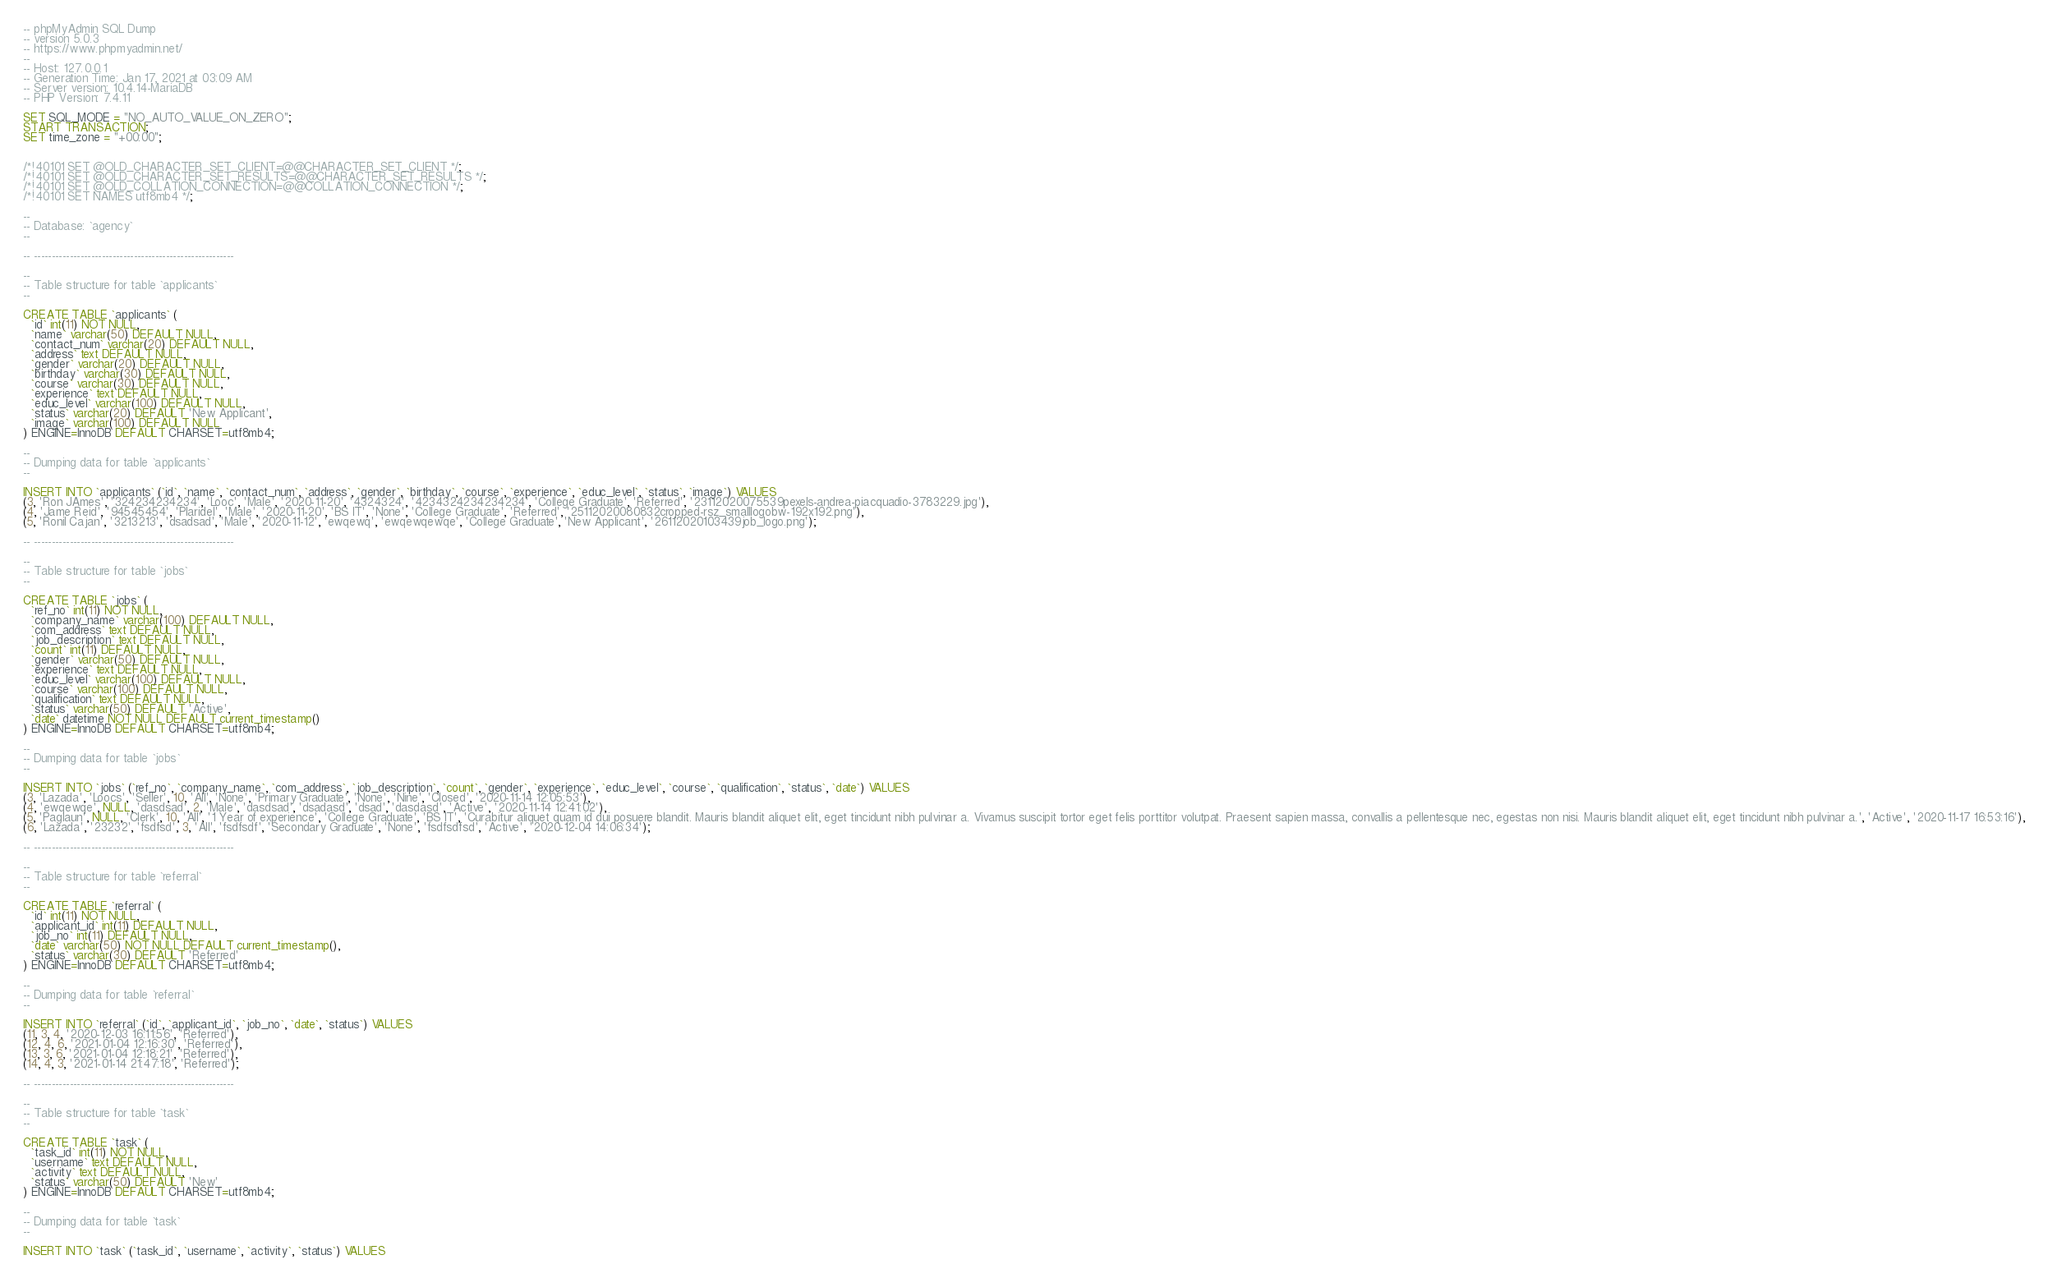Convert code to text. <code><loc_0><loc_0><loc_500><loc_500><_SQL_>-- phpMyAdmin SQL Dump
-- version 5.0.3
-- https://www.phpmyadmin.net/
--
-- Host: 127.0.0.1
-- Generation Time: Jan 17, 2021 at 03:09 AM
-- Server version: 10.4.14-MariaDB
-- PHP Version: 7.4.11

SET SQL_MODE = "NO_AUTO_VALUE_ON_ZERO";
START TRANSACTION;
SET time_zone = "+00:00";


/*!40101 SET @OLD_CHARACTER_SET_CLIENT=@@CHARACTER_SET_CLIENT */;
/*!40101 SET @OLD_CHARACTER_SET_RESULTS=@@CHARACTER_SET_RESULTS */;
/*!40101 SET @OLD_COLLATION_CONNECTION=@@COLLATION_CONNECTION */;
/*!40101 SET NAMES utf8mb4 */;

--
-- Database: `agency`
--

-- --------------------------------------------------------

--
-- Table structure for table `applicants`
--

CREATE TABLE `applicants` (
  `id` int(11) NOT NULL,
  `name` varchar(50) DEFAULT NULL,
  `contact_num` varchar(20) DEFAULT NULL,
  `address` text DEFAULT NULL,
  `gender` varchar(20) DEFAULT NULL,
  `birthday` varchar(30) DEFAULT NULL,
  `course` varchar(30) DEFAULT NULL,
  `experience` text DEFAULT NULL,
  `educ_level` varchar(100) DEFAULT NULL,
  `status` varchar(20) DEFAULT 'New Applicant',
  `image` varchar(100) DEFAULT NULL
) ENGINE=InnoDB DEFAULT CHARSET=utf8mb4;

--
-- Dumping data for table `applicants`
--

INSERT INTO `applicants` (`id`, `name`, `contact_num`, `address`, `gender`, `birthday`, `course`, `experience`, `educ_level`, `status`, `image`) VALUES
(3, 'Ron JAmes', '324234234234', 'Looc', 'Male', '2020-11-20', '4324324', '4234324234234234', 'College Graduate', 'Referred', '23112020075539pexels-andrea-piacquadio-3783229.jpg'),
(4, 'Jame Reid', '94545454', 'Plaridel', 'Male', '2020-11-20', 'BS IT', 'None', 'College Graduate', 'Referred', '25112020080832cropped-rsz_smalllogobw-192x192.png'),
(5, 'Ronil Cajan', '3213213', 'dsadsad', 'Male', '2020-11-12', 'ewqewq', 'ewqewqewqe', 'College Graduate', 'New Applicant', '26112020103439job_logo.png');

-- --------------------------------------------------------

--
-- Table structure for table `jobs`
--

CREATE TABLE `jobs` (
  `ref_no` int(11) NOT NULL,
  `company_name` varchar(100) DEFAULT NULL,
  `com_address` text DEFAULT NULL,
  `job_description` text DEFAULT NULL,
  `count` int(11) DEFAULT NULL,
  `gender` varchar(50) DEFAULT NULL,
  `experience` text DEFAULT NULL,
  `educ_level` varchar(100) DEFAULT NULL,
  `course` varchar(100) DEFAULT NULL,
  `qualification` text DEFAULT NULL,
  `status` varchar(50) DEFAULT 'Active',
  `date` datetime NOT NULL DEFAULT current_timestamp()
) ENGINE=InnoDB DEFAULT CHARSET=utf8mb4;

--
-- Dumping data for table `jobs`
--

INSERT INTO `jobs` (`ref_no`, `company_name`, `com_address`, `job_description`, `count`, `gender`, `experience`, `educ_level`, `course`, `qualification`, `status`, `date`) VALUES
(3, 'Lazada', 'Loocs', 'Seller', 10, 'All', 'None', 'Primary Graduate', 'None', 'Nine', 'Closed', '2020-11-14 12:05:53'),
(4, 'ewqewqe', NULL, 'dasdsad', 2, 'Male', 'dasdsad', 'dsadasd', 'dsad', 'dasdasd', 'Active', '2020-11-14 12:41:02'),
(5, 'Paglaun', NULL, 'Clerk', 10, 'All', '1 Year of experience', 'College Graduate', 'BS IT', 'Curabitur aliquet quam id dui posuere blandit. Mauris blandit aliquet elit, eget tincidunt nibh pulvinar a. Vivamus suscipit tortor eget felis porttitor volutpat. Praesent sapien massa, convallis a pellentesque nec, egestas non nisi. Mauris blandit aliquet elit, eget tincidunt nibh pulvinar a.', 'Active', '2020-11-17 16:53:16'),
(6, 'Lazada', '23232', 'fsdfsd', 3, 'All', 'fsdfsdf', 'Secondary Graduate', 'None', 'fsdfsdfsd', 'Active', '2020-12-04 14:06:34');

-- --------------------------------------------------------

--
-- Table structure for table `referral`
--

CREATE TABLE `referral` (
  `id` int(11) NOT NULL,
  `applicant_id` int(11) DEFAULT NULL,
  `job_no` int(11) DEFAULT NULL,
  `date` varchar(50) NOT NULL DEFAULT current_timestamp(),
  `status` varchar(30) DEFAULT 'Referred'
) ENGINE=InnoDB DEFAULT CHARSET=utf8mb4;

--
-- Dumping data for table `referral`
--

INSERT INTO `referral` (`id`, `applicant_id`, `job_no`, `date`, `status`) VALUES
(11, 3, 4, '2020-12-03 16:11:56', 'Referred'),
(12, 4, 6, '2021-01-04 12:16:30', 'Referred'),
(13, 3, 6, '2021-01-04 12:18:21', 'Referred'),
(14, 4, 3, '2021-01-14 21:47:18', 'Referred');

-- --------------------------------------------------------

--
-- Table structure for table `task`
--

CREATE TABLE `task` (
  `task_id` int(11) NOT NULL,
  `username` text DEFAULT NULL,
  `activity` text DEFAULT NULL,
  `status` varchar(50) DEFAULT 'New'
) ENGINE=InnoDB DEFAULT CHARSET=utf8mb4;

--
-- Dumping data for table `task`
--

INSERT INTO `task` (`task_id`, `username`, `activity`, `status`) VALUES</code> 